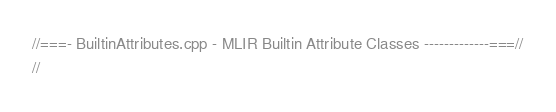<code> <loc_0><loc_0><loc_500><loc_500><_C++_>//===- BuiltinAttributes.cpp - MLIR Builtin Attribute Classes -------------===//
//</code> 